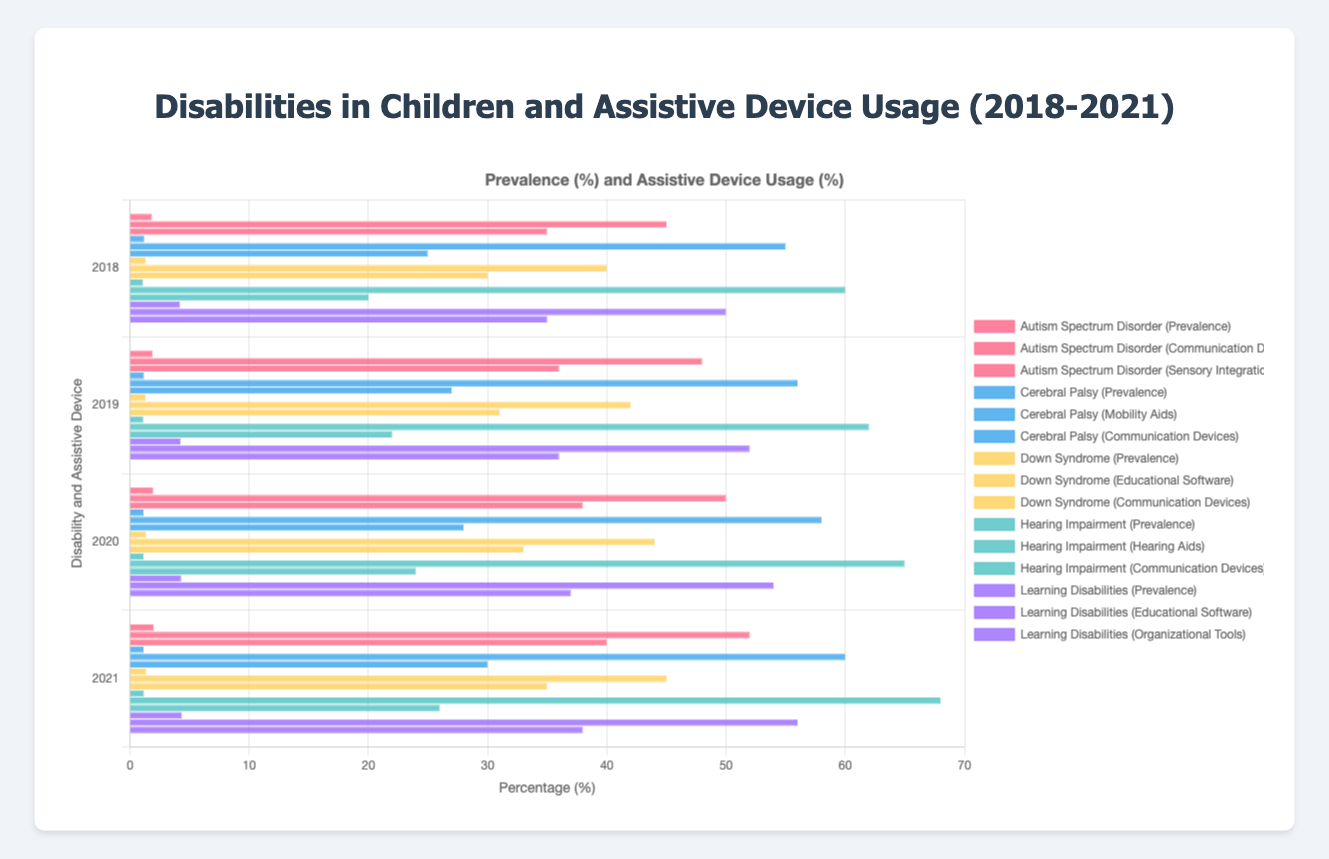What is the prevalence of Autism Spectrum Disorder in 2018 and 2021? To find the prevalence of Autism Spectrum Disorder, look at the corresponding bar segments in the chart's grouped section for Autism Spectrum Disorder labeled "2018" and "2021". For 2018, it is 1.85%, and for 2021, it is 2.00%.
Answer: 1.85%, 2.00% Which disability had the highest usage of mobility aids in 2021? Identify the bars representing mobility aids for each disability in 2021. The highest value is for Cerebral Palsy with 60%.
Answer: Cerebral Palsy Are the communication devices' usage higher for Autism Spectrum Disorder or Down Syndrome in 2020? Look at the bars for communication devices for Autism Spectrum Disorder (50%) and Down Syndrome (33%) in 2020. Autism Spectrum Disorder has higher usage.
Answer: Autism Spectrum Disorder What is the average prevalence rate of Learning Disabilities from 2018 to 2021? Add the prevalence rates from 2018 to 2021 (4.20, 4.25, 4.30, 4.35) and divide by the number of years. The average rate is (4.20 + 4.25 + 4.30 + 4.35) / 4 = 4.275 %.
Answer: 4.275% Which assistive device saw the biggest increase in usage for Hearing Impairment from 2018 to 2021? Compare the bar lengths for Hearing Aids and Communication Devices from 2018 to 2021. Hearing Aids increased from 60% to 68%, while Communication Devices increased from 20% to 26%. The increase for Hearing Aids is larger (8% vs. 6%).
Answer: Hearing Aids Did the prevalence of Cerebral Palsy increase or decrease from 2018 to 2021? Look at the bars for the prevalence of Cerebral Palsy from 2018 to 2021. The values are 1.20, 1.18, 1.15, and 1.13, indicating a decrease over the years.
Answer: Decrease Between 2018 and 2021, which year saw the highest percentage usage of communication devices for children with Down Syndrome? Compare the bar lengths labeled as Communication Devices for Down Syndrome in each year. The highest is in 2021 with 35%.
Answer: 2021 What is the difference in the prevalence of Down Syndrome between 2018 and 2020? The prevalence in 2018 is 1.30% and in 2020 is 1.35%, so the difference is 1.35% - 1.30% = 0.05%.
Answer: 0.05% For Learning Disabilities, what is the combined percentage usage of educational software and organizational tools in 2020? Add the percentages for Educational Software (54%) and Organizational Tools (37%) in 2020. The combined usage is 54% + 37% = 91%.
Answer: 91% What is the overall trend in the prevalence of Hearing Impairment from 2018 to 2021? Look at the prevalence bar lengths for Hearing Impairment from 2018 to 2021 (1.10, 1.12, 1.15, 1.18). There is an increasing trend.
Answer: Increasing 